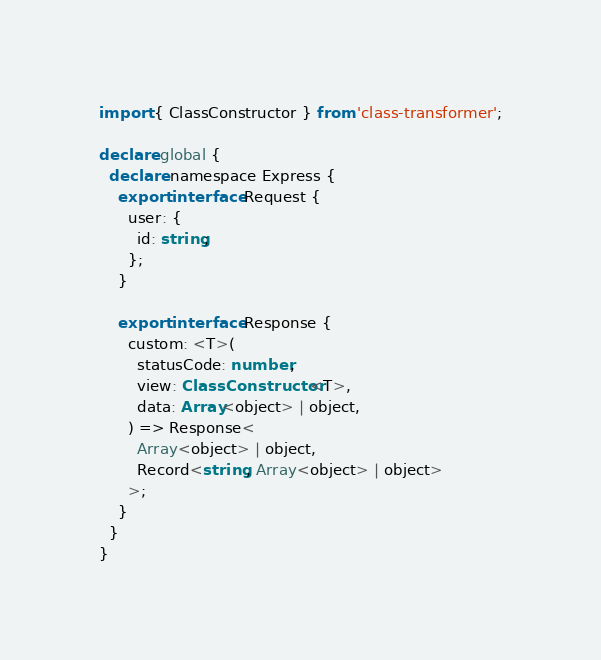Convert code to text. <code><loc_0><loc_0><loc_500><loc_500><_TypeScript_>import { ClassConstructor } from 'class-transformer';

declare global {
  declare namespace Express {
    export interface Request {
      user: {
        id: string;
      };
    }

    export interface Response {
      custom: <T>(
        statusCode: number,
        view: ClassConstructor<T>,
        data: Array<object> | object,
      ) => Response<
        Array<object> | object,
        Record<string, Array<object> | object>
      >;
    }
  }
}
</code> 